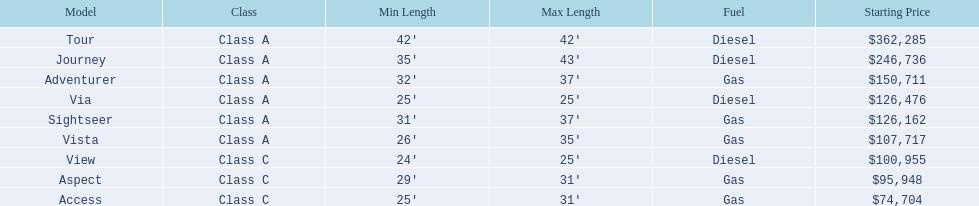Which model is a diesel, the tour or the aspect? Tour. 